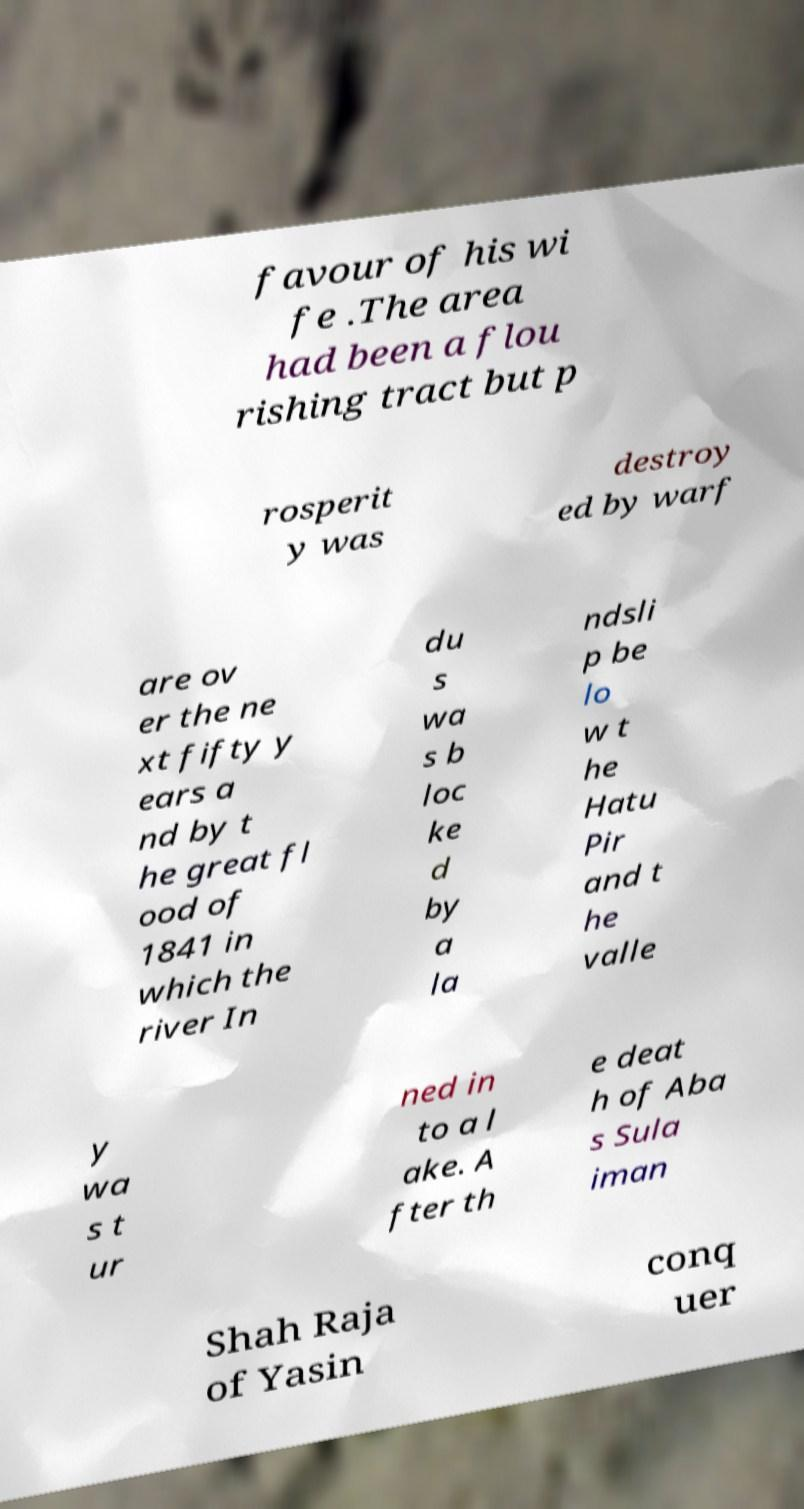Could you extract and type out the text from this image? favour of his wi fe .The area had been a flou rishing tract but p rosperit y was destroy ed by warf are ov er the ne xt fifty y ears a nd by t he great fl ood of 1841 in which the river In du s wa s b loc ke d by a la ndsli p be lo w t he Hatu Pir and t he valle y wa s t ur ned in to a l ake. A fter th e deat h of Aba s Sula iman Shah Raja of Yasin conq uer 